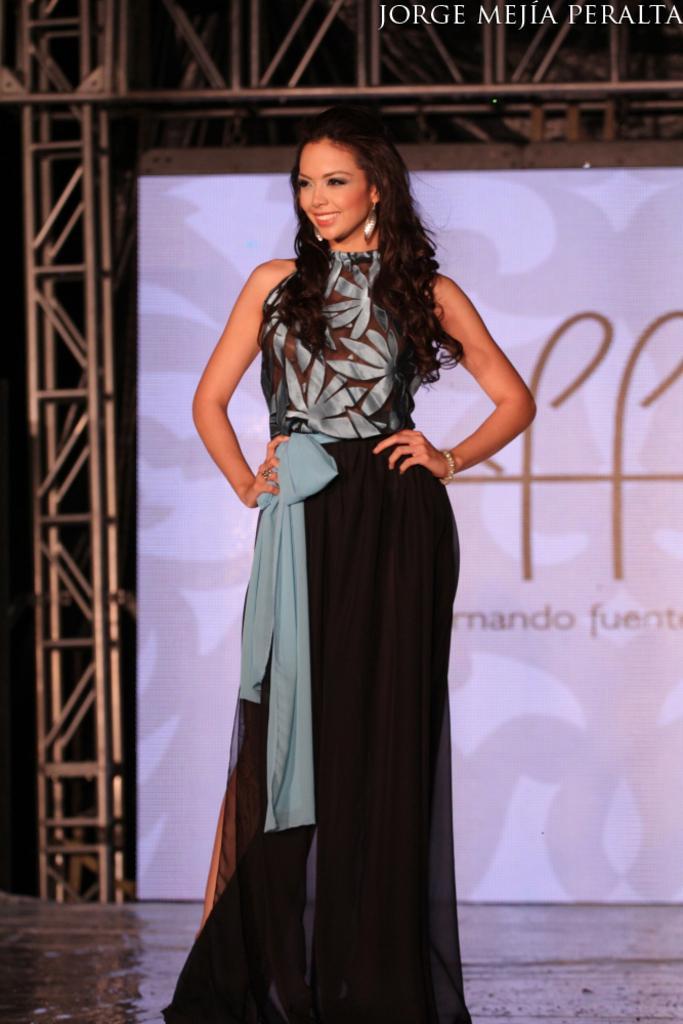Could you give a brief overview of what you see in this image? In this image we can see a woman standing and smiling, in the background, we can see a banner with some text on it and also we can see some metal rods. 